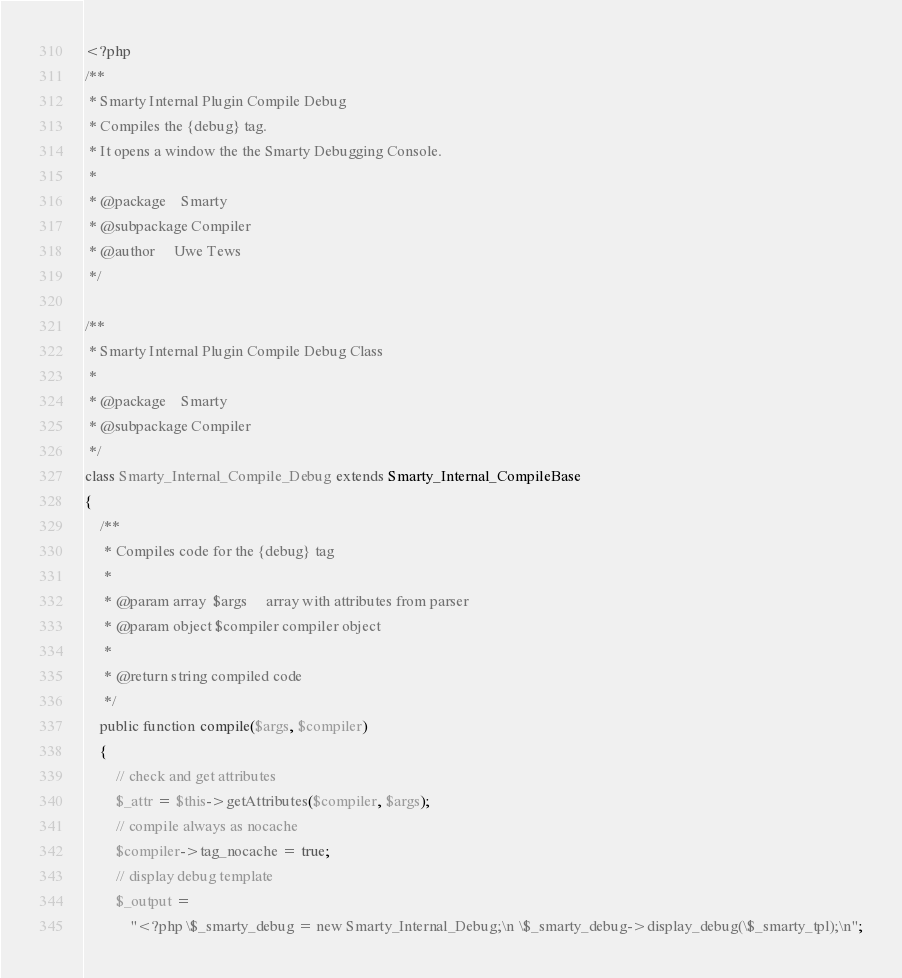Convert code to text. <code><loc_0><loc_0><loc_500><loc_500><_PHP_><?php
/**
 * Smarty Internal Plugin Compile Debug
 * Compiles the {debug} tag.
 * It opens a window the the Smarty Debugging Console.
 *
 * @package    Smarty
 * @subpackage Compiler
 * @author     Uwe Tews
 */

/**
 * Smarty Internal Plugin Compile Debug Class
 *
 * @package    Smarty
 * @subpackage Compiler
 */
class Smarty_Internal_Compile_Debug extends Smarty_Internal_CompileBase
{
    /**
     * Compiles code for the {debug} tag
     *
     * @param array  $args     array with attributes from parser
     * @param object $compiler compiler object
     *
     * @return string compiled code
     */
    public function compile($args, $compiler)
    {
        // check and get attributes
        $_attr = $this->getAttributes($compiler, $args);
        // compile always as nocache
        $compiler->tag_nocache = true;
        // display debug template
        $_output =
            "<?php \$_smarty_debug = new Smarty_Internal_Debug;\n \$_smarty_debug->display_debug(\$_smarty_tpl);\n";</code> 